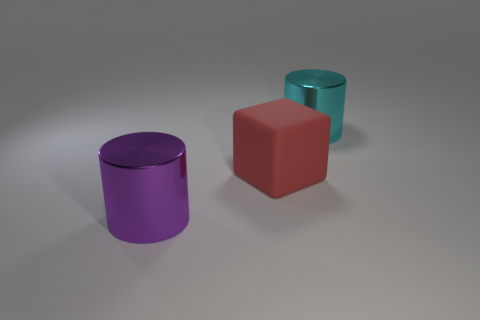Add 3 large rubber objects. How many objects exist? 6 Subtract all cylinders. How many objects are left? 1 Subtract all large purple cylinders. Subtract all red blocks. How many objects are left? 1 Add 1 cyan objects. How many cyan objects are left? 2 Add 3 cyan metal cylinders. How many cyan metal cylinders exist? 4 Subtract 0 blue cylinders. How many objects are left? 3 Subtract all yellow cubes. Subtract all brown cylinders. How many cubes are left? 1 